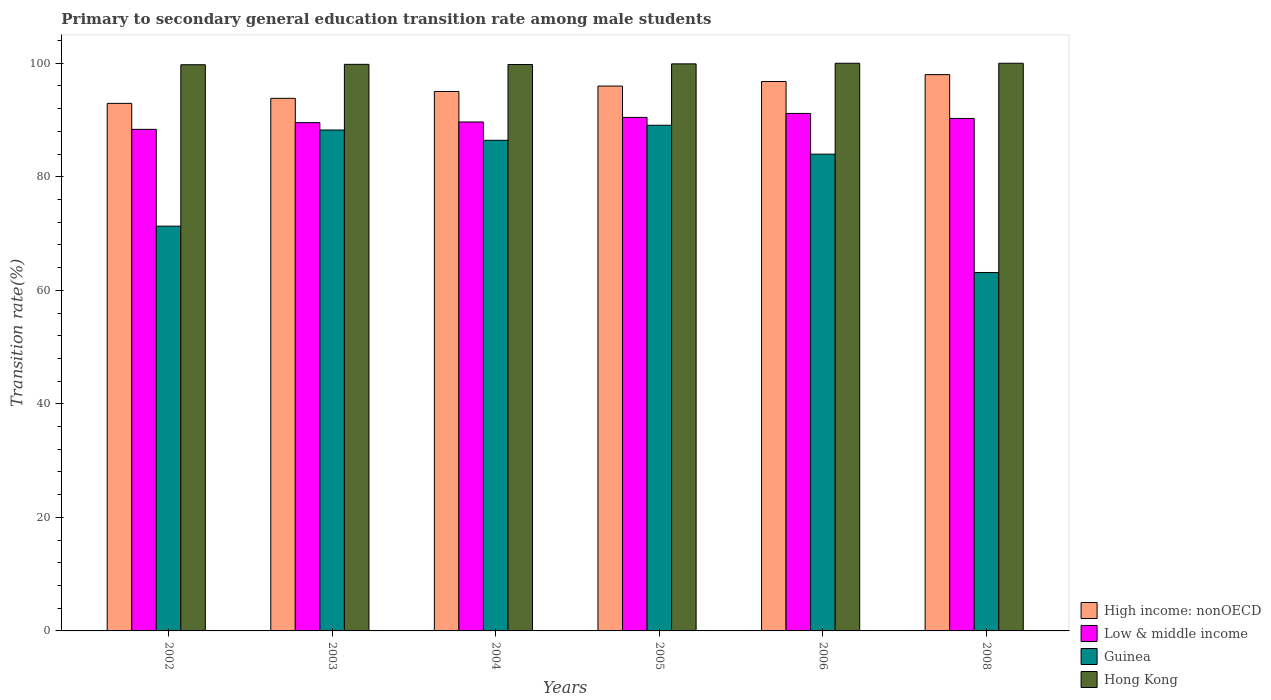Are the number of bars per tick equal to the number of legend labels?
Your response must be concise. Yes. Are the number of bars on each tick of the X-axis equal?
Keep it short and to the point. Yes. How many bars are there on the 6th tick from the right?
Give a very brief answer. 4. In how many cases, is the number of bars for a given year not equal to the number of legend labels?
Your response must be concise. 0. What is the transition rate in High income: nonOECD in 2003?
Give a very brief answer. 93.82. Across all years, what is the minimum transition rate in Hong Kong?
Your response must be concise. 99.74. What is the total transition rate in Hong Kong in the graph?
Keep it short and to the point. 599.22. What is the difference between the transition rate in Low & middle income in 2005 and that in 2008?
Keep it short and to the point. 0.18. What is the difference between the transition rate in Hong Kong in 2008 and the transition rate in Guinea in 2003?
Keep it short and to the point. 11.76. What is the average transition rate in Hong Kong per year?
Your answer should be very brief. 99.87. In the year 2003, what is the difference between the transition rate in High income: nonOECD and transition rate in Guinea?
Offer a terse response. 5.58. In how many years, is the transition rate in Hong Kong greater than 72 %?
Your answer should be compact. 6. What is the ratio of the transition rate in Guinea in 2003 to that in 2008?
Make the answer very short. 1.4. Is the difference between the transition rate in High income: nonOECD in 2002 and 2005 greater than the difference between the transition rate in Guinea in 2002 and 2005?
Offer a very short reply. Yes. What is the difference between the highest and the second highest transition rate in Guinea?
Provide a short and direct response. 0.84. What is the difference between the highest and the lowest transition rate in Guinea?
Offer a very short reply. 25.94. Is it the case that in every year, the sum of the transition rate in High income: nonOECD and transition rate in Guinea is greater than the sum of transition rate in Hong Kong and transition rate in Low & middle income?
Provide a succinct answer. Yes. What does the 1st bar from the right in 2005 represents?
Provide a succinct answer. Hong Kong. Is it the case that in every year, the sum of the transition rate in Hong Kong and transition rate in Guinea is greater than the transition rate in High income: nonOECD?
Your answer should be compact. Yes. What is the difference between two consecutive major ticks on the Y-axis?
Keep it short and to the point. 20. Are the values on the major ticks of Y-axis written in scientific E-notation?
Give a very brief answer. No. Does the graph contain any zero values?
Your answer should be compact. No. How many legend labels are there?
Your answer should be compact. 4. What is the title of the graph?
Give a very brief answer. Primary to secondary general education transition rate among male students. What is the label or title of the X-axis?
Offer a terse response. Years. What is the label or title of the Y-axis?
Make the answer very short. Transition rate(%). What is the Transition rate(%) in High income: nonOECD in 2002?
Provide a succinct answer. 92.93. What is the Transition rate(%) of Low & middle income in 2002?
Ensure brevity in your answer.  88.36. What is the Transition rate(%) in Guinea in 2002?
Ensure brevity in your answer.  71.3. What is the Transition rate(%) of Hong Kong in 2002?
Provide a short and direct response. 99.74. What is the Transition rate(%) of High income: nonOECD in 2003?
Give a very brief answer. 93.82. What is the Transition rate(%) in Low & middle income in 2003?
Provide a short and direct response. 89.54. What is the Transition rate(%) in Guinea in 2003?
Offer a very short reply. 88.24. What is the Transition rate(%) in Hong Kong in 2003?
Make the answer very short. 99.81. What is the Transition rate(%) of High income: nonOECD in 2004?
Keep it short and to the point. 95.03. What is the Transition rate(%) of Low & middle income in 2004?
Ensure brevity in your answer.  89.66. What is the Transition rate(%) in Guinea in 2004?
Offer a terse response. 86.43. What is the Transition rate(%) of Hong Kong in 2004?
Make the answer very short. 99.78. What is the Transition rate(%) of High income: nonOECD in 2005?
Your answer should be compact. 95.98. What is the Transition rate(%) of Low & middle income in 2005?
Your answer should be compact. 90.46. What is the Transition rate(%) in Guinea in 2005?
Offer a terse response. 89.08. What is the Transition rate(%) of Hong Kong in 2005?
Provide a short and direct response. 99.89. What is the Transition rate(%) in High income: nonOECD in 2006?
Offer a very short reply. 96.79. What is the Transition rate(%) in Low & middle income in 2006?
Your response must be concise. 91.16. What is the Transition rate(%) of Guinea in 2006?
Your response must be concise. 83.99. What is the Transition rate(%) of High income: nonOECD in 2008?
Your answer should be compact. 98. What is the Transition rate(%) in Low & middle income in 2008?
Provide a short and direct response. 90.28. What is the Transition rate(%) of Guinea in 2008?
Give a very brief answer. 63.14. Across all years, what is the maximum Transition rate(%) of High income: nonOECD?
Ensure brevity in your answer.  98. Across all years, what is the maximum Transition rate(%) in Low & middle income?
Offer a terse response. 91.16. Across all years, what is the maximum Transition rate(%) in Guinea?
Offer a terse response. 89.08. Across all years, what is the minimum Transition rate(%) of High income: nonOECD?
Provide a short and direct response. 92.93. Across all years, what is the minimum Transition rate(%) of Low & middle income?
Offer a very short reply. 88.36. Across all years, what is the minimum Transition rate(%) in Guinea?
Make the answer very short. 63.14. Across all years, what is the minimum Transition rate(%) in Hong Kong?
Ensure brevity in your answer.  99.74. What is the total Transition rate(%) in High income: nonOECD in the graph?
Your response must be concise. 572.55. What is the total Transition rate(%) in Low & middle income in the graph?
Provide a short and direct response. 539.45. What is the total Transition rate(%) in Guinea in the graph?
Keep it short and to the point. 482.18. What is the total Transition rate(%) of Hong Kong in the graph?
Offer a very short reply. 599.22. What is the difference between the Transition rate(%) of High income: nonOECD in 2002 and that in 2003?
Make the answer very short. -0.88. What is the difference between the Transition rate(%) in Low & middle income in 2002 and that in 2003?
Keep it short and to the point. -1.18. What is the difference between the Transition rate(%) in Guinea in 2002 and that in 2003?
Provide a succinct answer. -16.94. What is the difference between the Transition rate(%) in Hong Kong in 2002 and that in 2003?
Provide a short and direct response. -0.07. What is the difference between the Transition rate(%) in High income: nonOECD in 2002 and that in 2004?
Your answer should be compact. -2.09. What is the difference between the Transition rate(%) of Low & middle income in 2002 and that in 2004?
Offer a terse response. -1.3. What is the difference between the Transition rate(%) of Guinea in 2002 and that in 2004?
Make the answer very short. -15.13. What is the difference between the Transition rate(%) in Hong Kong in 2002 and that in 2004?
Provide a succinct answer. -0.04. What is the difference between the Transition rate(%) of High income: nonOECD in 2002 and that in 2005?
Your answer should be very brief. -3.05. What is the difference between the Transition rate(%) in Low & middle income in 2002 and that in 2005?
Keep it short and to the point. -2.1. What is the difference between the Transition rate(%) in Guinea in 2002 and that in 2005?
Ensure brevity in your answer.  -17.78. What is the difference between the Transition rate(%) of Hong Kong in 2002 and that in 2005?
Your response must be concise. -0.16. What is the difference between the Transition rate(%) of High income: nonOECD in 2002 and that in 2006?
Give a very brief answer. -3.85. What is the difference between the Transition rate(%) in Low & middle income in 2002 and that in 2006?
Provide a short and direct response. -2.81. What is the difference between the Transition rate(%) in Guinea in 2002 and that in 2006?
Your answer should be very brief. -12.68. What is the difference between the Transition rate(%) in Hong Kong in 2002 and that in 2006?
Keep it short and to the point. -0.26. What is the difference between the Transition rate(%) in High income: nonOECD in 2002 and that in 2008?
Give a very brief answer. -5.06. What is the difference between the Transition rate(%) in Low & middle income in 2002 and that in 2008?
Provide a short and direct response. -1.92. What is the difference between the Transition rate(%) in Guinea in 2002 and that in 2008?
Keep it short and to the point. 8.16. What is the difference between the Transition rate(%) in Hong Kong in 2002 and that in 2008?
Keep it short and to the point. -0.26. What is the difference between the Transition rate(%) of High income: nonOECD in 2003 and that in 2004?
Your answer should be compact. -1.21. What is the difference between the Transition rate(%) of Low & middle income in 2003 and that in 2004?
Your answer should be compact. -0.12. What is the difference between the Transition rate(%) in Guinea in 2003 and that in 2004?
Provide a succinct answer. 1.81. What is the difference between the Transition rate(%) in Hong Kong in 2003 and that in 2004?
Ensure brevity in your answer.  0.03. What is the difference between the Transition rate(%) in High income: nonOECD in 2003 and that in 2005?
Provide a succinct answer. -2.16. What is the difference between the Transition rate(%) of Low & middle income in 2003 and that in 2005?
Provide a short and direct response. -0.92. What is the difference between the Transition rate(%) of Guinea in 2003 and that in 2005?
Keep it short and to the point. -0.84. What is the difference between the Transition rate(%) of Hong Kong in 2003 and that in 2005?
Offer a terse response. -0.08. What is the difference between the Transition rate(%) in High income: nonOECD in 2003 and that in 2006?
Offer a very short reply. -2.97. What is the difference between the Transition rate(%) of Low & middle income in 2003 and that in 2006?
Your answer should be very brief. -1.63. What is the difference between the Transition rate(%) of Guinea in 2003 and that in 2006?
Ensure brevity in your answer.  4.25. What is the difference between the Transition rate(%) in Hong Kong in 2003 and that in 2006?
Provide a short and direct response. -0.19. What is the difference between the Transition rate(%) in High income: nonOECD in 2003 and that in 2008?
Provide a succinct answer. -4.18. What is the difference between the Transition rate(%) in Low & middle income in 2003 and that in 2008?
Offer a terse response. -0.74. What is the difference between the Transition rate(%) of Guinea in 2003 and that in 2008?
Offer a very short reply. 25.1. What is the difference between the Transition rate(%) in Hong Kong in 2003 and that in 2008?
Your answer should be very brief. -0.19. What is the difference between the Transition rate(%) in High income: nonOECD in 2004 and that in 2005?
Ensure brevity in your answer.  -0.95. What is the difference between the Transition rate(%) of Low & middle income in 2004 and that in 2005?
Make the answer very short. -0.8. What is the difference between the Transition rate(%) of Guinea in 2004 and that in 2005?
Your answer should be compact. -2.65. What is the difference between the Transition rate(%) of Hong Kong in 2004 and that in 2005?
Your answer should be compact. -0.11. What is the difference between the Transition rate(%) of High income: nonOECD in 2004 and that in 2006?
Give a very brief answer. -1.76. What is the difference between the Transition rate(%) in Low & middle income in 2004 and that in 2006?
Your answer should be compact. -1.51. What is the difference between the Transition rate(%) in Guinea in 2004 and that in 2006?
Keep it short and to the point. 2.44. What is the difference between the Transition rate(%) in Hong Kong in 2004 and that in 2006?
Offer a terse response. -0.22. What is the difference between the Transition rate(%) in High income: nonOECD in 2004 and that in 2008?
Ensure brevity in your answer.  -2.97. What is the difference between the Transition rate(%) of Low & middle income in 2004 and that in 2008?
Give a very brief answer. -0.62. What is the difference between the Transition rate(%) of Guinea in 2004 and that in 2008?
Your answer should be very brief. 23.29. What is the difference between the Transition rate(%) of Hong Kong in 2004 and that in 2008?
Keep it short and to the point. -0.22. What is the difference between the Transition rate(%) of High income: nonOECD in 2005 and that in 2006?
Provide a succinct answer. -0.8. What is the difference between the Transition rate(%) of Low & middle income in 2005 and that in 2006?
Offer a very short reply. -0.7. What is the difference between the Transition rate(%) of Guinea in 2005 and that in 2006?
Ensure brevity in your answer.  5.09. What is the difference between the Transition rate(%) in Hong Kong in 2005 and that in 2006?
Ensure brevity in your answer.  -0.11. What is the difference between the Transition rate(%) in High income: nonOECD in 2005 and that in 2008?
Offer a terse response. -2.01. What is the difference between the Transition rate(%) of Low & middle income in 2005 and that in 2008?
Offer a very short reply. 0.18. What is the difference between the Transition rate(%) in Guinea in 2005 and that in 2008?
Your answer should be compact. 25.94. What is the difference between the Transition rate(%) in Hong Kong in 2005 and that in 2008?
Give a very brief answer. -0.11. What is the difference between the Transition rate(%) of High income: nonOECD in 2006 and that in 2008?
Provide a succinct answer. -1.21. What is the difference between the Transition rate(%) in Low & middle income in 2006 and that in 2008?
Offer a very short reply. 0.88. What is the difference between the Transition rate(%) of Guinea in 2006 and that in 2008?
Provide a short and direct response. 20.84. What is the difference between the Transition rate(%) of Hong Kong in 2006 and that in 2008?
Make the answer very short. 0. What is the difference between the Transition rate(%) in High income: nonOECD in 2002 and the Transition rate(%) in Low & middle income in 2003?
Your answer should be compact. 3.4. What is the difference between the Transition rate(%) in High income: nonOECD in 2002 and the Transition rate(%) in Guinea in 2003?
Make the answer very short. 4.69. What is the difference between the Transition rate(%) of High income: nonOECD in 2002 and the Transition rate(%) of Hong Kong in 2003?
Offer a terse response. -6.88. What is the difference between the Transition rate(%) in Low & middle income in 2002 and the Transition rate(%) in Guinea in 2003?
Offer a terse response. 0.12. What is the difference between the Transition rate(%) in Low & middle income in 2002 and the Transition rate(%) in Hong Kong in 2003?
Your answer should be compact. -11.45. What is the difference between the Transition rate(%) in Guinea in 2002 and the Transition rate(%) in Hong Kong in 2003?
Your answer should be compact. -28.51. What is the difference between the Transition rate(%) in High income: nonOECD in 2002 and the Transition rate(%) in Low & middle income in 2004?
Give a very brief answer. 3.28. What is the difference between the Transition rate(%) in High income: nonOECD in 2002 and the Transition rate(%) in Guinea in 2004?
Provide a succinct answer. 6.51. What is the difference between the Transition rate(%) in High income: nonOECD in 2002 and the Transition rate(%) in Hong Kong in 2004?
Your answer should be compact. -6.85. What is the difference between the Transition rate(%) in Low & middle income in 2002 and the Transition rate(%) in Guinea in 2004?
Provide a succinct answer. 1.93. What is the difference between the Transition rate(%) of Low & middle income in 2002 and the Transition rate(%) of Hong Kong in 2004?
Make the answer very short. -11.42. What is the difference between the Transition rate(%) in Guinea in 2002 and the Transition rate(%) in Hong Kong in 2004?
Provide a succinct answer. -28.48. What is the difference between the Transition rate(%) in High income: nonOECD in 2002 and the Transition rate(%) in Low & middle income in 2005?
Your answer should be very brief. 2.48. What is the difference between the Transition rate(%) in High income: nonOECD in 2002 and the Transition rate(%) in Guinea in 2005?
Give a very brief answer. 3.86. What is the difference between the Transition rate(%) of High income: nonOECD in 2002 and the Transition rate(%) of Hong Kong in 2005?
Offer a terse response. -6.96. What is the difference between the Transition rate(%) of Low & middle income in 2002 and the Transition rate(%) of Guinea in 2005?
Offer a very short reply. -0.72. What is the difference between the Transition rate(%) in Low & middle income in 2002 and the Transition rate(%) in Hong Kong in 2005?
Ensure brevity in your answer.  -11.54. What is the difference between the Transition rate(%) of Guinea in 2002 and the Transition rate(%) of Hong Kong in 2005?
Your answer should be very brief. -28.59. What is the difference between the Transition rate(%) in High income: nonOECD in 2002 and the Transition rate(%) in Low & middle income in 2006?
Offer a very short reply. 1.77. What is the difference between the Transition rate(%) of High income: nonOECD in 2002 and the Transition rate(%) of Guinea in 2006?
Offer a terse response. 8.95. What is the difference between the Transition rate(%) of High income: nonOECD in 2002 and the Transition rate(%) of Hong Kong in 2006?
Provide a succinct answer. -7.07. What is the difference between the Transition rate(%) of Low & middle income in 2002 and the Transition rate(%) of Guinea in 2006?
Give a very brief answer. 4.37. What is the difference between the Transition rate(%) in Low & middle income in 2002 and the Transition rate(%) in Hong Kong in 2006?
Ensure brevity in your answer.  -11.64. What is the difference between the Transition rate(%) in Guinea in 2002 and the Transition rate(%) in Hong Kong in 2006?
Offer a very short reply. -28.7. What is the difference between the Transition rate(%) of High income: nonOECD in 2002 and the Transition rate(%) of Low & middle income in 2008?
Provide a short and direct response. 2.66. What is the difference between the Transition rate(%) of High income: nonOECD in 2002 and the Transition rate(%) of Guinea in 2008?
Your answer should be very brief. 29.79. What is the difference between the Transition rate(%) in High income: nonOECD in 2002 and the Transition rate(%) in Hong Kong in 2008?
Ensure brevity in your answer.  -7.07. What is the difference between the Transition rate(%) of Low & middle income in 2002 and the Transition rate(%) of Guinea in 2008?
Your answer should be compact. 25.21. What is the difference between the Transition rate(%) of Low & middle income in 2002 and the Transition rate(%) of Hong Kong in 2008?
Your answer should be very brief. -11.64. What is the difference between the Transition rate(%) of Guinea in 2002 and the Transition rate(%) of Hong Kong in 2008?
Offer a very short reply. -28.7. What is the difference between the Transition rate(%) of High income: nonOECD in 2003 and the Transition rate(%) of Low & middle income in 2004?
Give a very brief answer. 4.16. What is the difference between the Transition rate(%) in High income: nonOECD in 2003 and the Transition rate(%) in Guinea in 2004?
Make the answer very short. 7.39. What is the difference between the Transition rate(%) of High income: nonOECD in 2003 and the Transition rate(%) of Hong Kong in 2004?
Offer a terse response. -5.96. What is the difference between the Transition rate(%) in Low & middle income in 2003 and the Transition rate(%) in Guinea in 2004?
Your answer should be very brief. 3.11. What is the difference between the Transition rate(%) in Low & middle income in 2003 and the Transition rate(%) in Hong Kong in 2004?
Offer a very short reply. -10.24. What is the difference between the Transition rate(%) in Guinea in 2003 and the Transition rate(%) in Hong Kong in 2004?
Your answer should be very brief. -11.54. What is the difference between the Transition rate(%) of High income: nonOECD in 2003 and the Transition rate(%) of Low & middle income in 2005?
Your answer should be very brief. 3.36. What is the difference between the Transition rate(%) of High income: nonOECD in 2003 and the Transition rate(%) of Guinea in 2005?
Give a very brief answer. 4.74. What is the difference between the Transition rate(%) in High income: nonOECD in 2003 and the Transition rate(%) in Hong Kong in 2005?
Provide a short and direct response. -6.07. What is the difference between the Transition rate(%) of Low & middle income in 2003 and the Transition rate(%) of Guinea in 2005?
Keep it short and to the point. 0.46. What is the difference between the Transition rate(%) in Low & middle income in 2003 and the Transition rate(%) in Hong Kong in 2005?
Make the answer very short. -10.36. What is the difference between the Transition rate(%) in Guinea in 2003 and the Transition rate(%) in Hong Kong in 2005?
Keep it short and to the point. -11.65. What is the difference between the Transition rate(%) of High income: nonOECD in 2003 and the Transition rate(%) of Low & middle income in 2006?
Give a very brief answer. 2.66. What is the difference between the Transition rate(%) of High income: nonOECD in 2003 and the Transition rate(%) of Guinea in 2006?
Offer a very short reply. 9.83. What is the difference between the Transition rate(%) in High income: nonOECD in 2003 and the Transition rate(%) in Hong Kong in 2006?
Your answer should be compact. -6.18. What is the difference between the Transition rate(%) of Low & middle income in 2003 and the Transition rate(%) of Guinea in 2006?
Ensure brevity in your answer.  5.55. What is the difference between the Transition rate(%) of Low & middle income in 2003 and the Transition rate(%) of Hong Kong in 2006?
Offer a terse response. -10.46. What is the difference between the Transition rate(%) in Guinea in 2003 and the Transition rate(%) in Hong Kong in 2006?
Ensure brevity in your answer.  -11.76. What is the difference between the Transition rate(%) of High income: nonOECD in 2003 and the Transition rate(%) of Low & middle income in 2008?
Your response must be concise. 3.54. What is the difference between the Transition rate(%) in High income: nonOECD in 2003 and the Transition rate(%) in Guinea in 2008?
Provide a short and direct response. 30.68. What is the difference between the Transition rate(%) in High income: nonOECD in 2003 and the Transition rate(%) in Hong Kong in 2008?
Ensure brevity in your answer.  -6.18. What is the difference between the Transition rate(%) in Low & middle income in 2003 and the Transition rate(%) in Guinea in 2008?
Offer a very short reply. 26.4. What is the difference between the Transition rate(%) of Low & middle income in 2003 and the Transition rate(%) of Hong Kong in 2008?
Your response must be concise. -10.46. What is the difference between the Transition rate(%) of Guinea in 2003 and the Transition rate(%) of Hong Kong in 2008?
Ensure brevity in your answer.  -11.76. What is the difference between the Transition rate(%) of High income: nonOECD in 2004 and the Transition rate(%) of Low & middle income in 2005?
Provide a short and direct response. 4.57. What is the difference between the Transition rate(%) of High income: nonOECD in 2004 and the Transition rate(%) of Guinea in 2005?
Your answer should be very brief. 5.95. What is the difference between the Transition rate(%) in High income: nonOECD in 2004 and the Transition rate(%) in Hong Kong in 2005?
Your response must be concise. -4.87. What is the difference between the Transition rate(%) in Low & middle income in 2004 and the Transition rate(%) in Guinea in 2005?
Offer a very short reply. 0.58. What is the difference between the Transition rate(%) in Low & middle income in 2004 and the Transition rate(%) in Hong Kong in 2005?
Keep it short and to the point. -10.24. What is the difference between the Transition rate(%) in Guinea in 2004 and the Transition rate(%) in Hong Kong in 2005?
Provide a short and direct response. -13.46. What is the difference between the Transition rate(%) in High income: nonOECD in 2004 and the Transition rate(%) in Low & middle income in 2006?
Provide a short and direct response. 3.87. What is the difference between the Transition rate(%) in High income: nonOECD in 2004 and the Transition rate(%) in Guinea in 2006?
Offer a very short reply. 11.04. What is the difference between the Transition rate(%) in High income: nonOECD in 2004 and the Transition rate(%) in Hong Kong in 2006?
Give a very brief answer. -4.97. What is the difference between the Transition rate(%) of Low & middle income in 2004 and the Transition rate(%) of Guinea in 2006?
Your answer should be compact. 5.67. What is the difference between the Transition rate(%) in Low & middle income in 2004 and the Transition rate(%) in Hong Kong in 2006?
Your response must be concise. -10.34. What is the difference between the Transition rate(%) in Guinea in 2004 and the Transition rate(%) in Hong Kong in 2006?
Give a very brief answer. -13.57. What is the difference between the Transition rate(%) of High income: nonOECD in 2004 and the Transition rate(%) of Low & middle income in 2008?
Keep it short and to the point. 4.75. What is the difference between the Transition rate(%) in High income: nonOECD in 2004 and the Transition rate(%) in Guinea in 2008?
Provide a succinct answer. 31.89. What is the difference between the Transition rate(%) of High income: nonOECD in 2004 and the Transition rate(%) of Hong Kong in 2008?
Provide a short and direct response. -4.97. What is the difference between the Transition rate(%) in Low & middle income in 2004 and the Transition rate(%) in Guinea in 2008?
Ensure brevity in your answer.  26.51. What is the difference between the Transition rate(%) of Low & middle income in 2004 and the Transition rate(%) of Hong Kong in 2008?
Ensure brevity in your answer.  -10.34. What is the difference between the Transition rate(%) of Guinea in 2004 and the Transition rate(%) of Hong Kong in 2008?
Make the answer very short. -13.57. What is the difference between the Transition rate(%) in High income: nonOECD in 2005 and the Transition rate(%) in Low & middle income in 2006?
Offer a terse response. 4.82. What is the difference between the Transition rate(%) of High income: nonOECD in 2005 and the Transition rate(%) of Guinea in 2006?
Ensure brevity in your answer.  12. What is the difference between the Transition rate(%) in High income: nonOECD in 2005 and the Transition rate(%) in Hong Kong in 2006?
Your answer should be very brief. -4.02. What is the difference between the Transition rate(%) of Low & middle income in 2005 and the Transition rate(%) of Guinea in 2006?
Provide a succinct answer. 6.47. What is the difference between the Transition rate(%) in Low & middle income in 2005 and the Transition rate(%) in Hong Kong in 2006?
Provide a short and direct response. -9.54. What is the difference between the Transition rate(%) in Guinea in 2005 and the Transition rate(%) in Hong Kong in 2006?
Provide a short and direct response. -10.92. What is the difference between the Transition rate(%) of High income: nonOECD in 2005 and the Transition rate(%) of Low & middle income in 2008?
Your answer should be compact. 5.7. What is the difference between the Transition rate(%) of High income: nonOECD in 2005 and the Transition rate(%) of Guinea in 2008?
Make the answer very short. 32.84. What is the difference between the Transition rate(%) in High income: nonOECD in 2005 and the Transition rate(%) in Hong Kong in 2008?
Your answer should be very brief. -4.02. What is the difference between the Transition rate(%) in Low & middle income in 2005 and the Transition rate(%) in Guinea in 2008?
Provide a short and direct response. 27.32. What is the difference between the Transition rate(%) of Low & middle income in 2005 and the Transition rate(%) of Hong Kong in 2008?
Your answer should be compact. -9.54. What is the difference between the Transition rate(%) in Guinea in 2005 and the Transition rate(%) in Hong Kong in 2008?
Make the answer very short. -10.92. What is the difference between the Transition rate(%) of High income: nonOECD in 2006 and the Transition rate(%) of Low & middle income in 2008?
Make the answer very short. 6.51. What is the difference between the Transition rate(%) in High income: nonOECD in 2006 and the Transition rate(%) in Guinea in 2008?
Ensure brevity in your answer.  33.64. What is the difference between the Transition rate(%) in High income: nonOECD in 2006 and the Transition rate(%) in Hong Kong in 2008?
Provide a short and direct response. -3.21. What is the difference between the Transition rate(%) in Low & middle income in 2006 and the Transition rate(%) in Guinea in 2008?
Provide a short and direct response. 28.02. What is the difference between the Transition rate(%) in Low & middle income in 2006 and the Transition rate(%) in Hong Kong in 2008?
Offer a terse response. -8.84. What is the difference between the Transition rate(%) of Guinea in 2006 and the Transition rate(%) of Hong Kong in 2008?
Make the answer very short. -16.01. What is the average Transition rate(%) in High income: nonOECD per year?
Make the answer very short. 95.42. What is the average Transition rate(%) of Low & middle income per year?
Your answer should be compact. 89.91. What is the average Transition rate(%) in Guinea per year?
Keep it short and to the point. 80.36. What is the average Transition rate(%) in Hong Kong per year?
Provide a short and direct response. 99.87. In the year 2002, what is the difference between the Transition rate(%) of High income: nonOECD and Transition rate(%) of Low & middle income?
Give a very brief answer. 4.58. In the year 2002, what is the difference between the Transition rate(%) of High income: nonOECD and Transition rate(%) of Guinea?
Keep it short and to the point. 21.63. In the year 2002, what is the difference between the Transition rate(%) of High income: nonOECD and Transition rate(%) of Hong Kong?
Keep it short and to the point. -6.8. In the year 2002, what is the difference between the Transition rate(%) of Low & middle income and Transition rate(%) of Guinea?
Give a very brief answer. 17.06. In the year 2002, what is the difference between the Transition rate(%) in Low & middle income and Transition rate(%) in Hong Kong?
Make the answer very short. -11.38. In the year 2002, what is the difference between the Transition rate(%) of Guinea and Transition rate(%) of Hong Kong?
Make the answer very short. -28.44. In the year 2003, what is the difference between the Transition rate(%) of High income: nonOECD and Transition rate(%) of Low & middle income?
Make the answer very short. 4.28. In the year 2003, what is the difference between the Transition rate(%) in High income: nonOECD and Transition rate(%) in Guinea?
Ensure brevity in your answer.  5.58. In the year 2003, what is the difference between the Transition rate(%) in High income: nonOECD and Transition rate(%) in Hong Kong?
Make the answer very short. -5.99. In the year 2003, what is the difference between the Transition rate(%) of Low & middle income and Transition rate(%) of Guinea?
Offer a terse response. 1.3. In the year 2003, what is the difference between the Transition rate(%) of Low & middle income and Transition rate(%) of Hong Kong?
Offer a terse response. -10.27. In the year 2003, what is the difference between the Transition rate(%) in Guinea and Transition rate(%) in Hong Kong?
Ensure brevity in your answer.  -11.57. In the year 2004, what is the difference between the Transition rate(%) in High income: nonOECD and Transition rate(%) in Low & middle income?
Your response must be concise. 5.37. In the year 2004, what is the difference between the Transition rate(%) of High income: nonOECD and Transition rate(%) of Guinea?
Provide a short and direct response. 8.6. In the year 2004, what is the difference between the Transition rate(%) in High income: nonOECD and Transition rate(%) in Hong Kong?
Your answer should be very brief. -4.75. In the year 2004, what is the difference between the Transition rate(%) in Low & middle income and Transition rate(%) in Guinea?
Your answer should be very brief. 3.23. In the year 2004, what is the difference between the Transition rate(%) in Low & middle income and Transition rate(%) in Hong Kong?
Provide a succinct answer. -10.12. In the year 2004, what is the difference between the Transition rate(%) in Guinea and Transition rate(%) in Hong Kong?
Your answer should be very brief. -13.35. In the year 2005, what is the difference between the Transition rate(%) of High income: nonOECD and Transition rate(%) of Low & middle income?
Keep it short and to the point. 5.52. In the year 2005, what is the difference between the Transition rate(%) of High income: nonOECD and Transition rate(%) of Guinea?
Give a very brief answer. 6.9. In the year 2005, what is the difference between the Transition rate(%) of High income: nonOECD and Transition rate(%) of Hong Kong?
Make the answer very short. -3.91. In the year 2005, what is the difference between the Transition rate(%) of Low & middle income and Transition rate(%) of Guinea?
Your response must be concise. 1.38. In the year 2005, what is the difference between the Transition rate(%) in Low & middle income and Transition rate(%) in Hong Kong?
Your response must be concise. -9.43. In the year 2005, what is the difference between the Transition rate(%) of Guinea and Transition rate(%) of Hong Kong?
Make the answer very short. -10.81. In the year 2006, what is the difference between the Transition rate(%) in High income: nonOECD and Transition rate(%) in Low & middle income?
Make the answer very short. 5.62. In the year 2006, what is the difference between the Transition rate(%) in High income: nonOECD and Transition rate(%) in Guinea?
Offer a terse response. 12.8. In the year 2006, what is the difference between the Transition rate(%) of High income: nonOECD and Transition rate(%) of Hong Kong?
Provide a short and direct response. -3.21. In the year 2006, what is the difference between the Transition rate(%) of Low & middle income and Transition rate(%) of Guinea?
Offer a terse response. 7.18. In the year 2006, what is the difference between the Transition rate(%) of Low & middle income and Transition rate(%) of Hong Kong?
Your answer should be very brief. -8.84. In the year 2006, what is the difference between the Transition rate(%) in Guinea and Transition rate(%) in Hong Kong?
Give a very brief answer. -16.01. In the year 2008, what is the difference between the Transition rate(%) of High income: nonOECD and Transition rate(%) of Low & middle income?
Your answer should be compact. 7.72. In the year 2008, what is the difference between the Transition rate(%) of High income: nonOECD and Transition rate(%) of Guinea?
Give a very brief answer. 34.85. In the year 2008, what is the difference between the Transition rate(%) in High income: nonOECD and Transition rate(%) in Hong Kong?
Give a very brief answer. -2. In the year 2008, what is the difference between the Transition rate(%) in Low & middle income and Transition rate(%) in Guinea?
Your answer should be compact. 27.14. In the year 2008, what is the difference between the Transition rate(%) in Low & middle income and Transition rate(%) in Hong Kong?
Offer a terse response. -9.72. In the year 2008, what is the difference between the Transition rate(%) of Guinea and Transition rate(%) of Hong Kong?
Provide a succinct answer. -36.86. What is the ratio of the Transition rate(%) in High income: nonOECD in 2002 to that in 2003?
Your answer should be compact. 0.99. What is the ratio of the Transition rate(%) of Guinea in 2002 to that in 2003?
Provide a succinct answer. 0.81. What is the ratio of the Transition rate(%) in Hong Kong in 2002 to that in 2003?
Keep it short and to the point. 1. What is the ratio of the Transition rate(%) of Low & middle income in 2002 to that in 2004?
Make the answer very short. 0.99. What is the ratio of the Transition rate(%) in Guinea in 2002 to that in 2004?
Your answer should be compact. 0.82. What is the ratio of the Transition rate(%) in Hong Kong in 2002 to that in 2004?
Your answer should be very brief. 1. What is the ratio of the Transition rate(%) of High income: nonOECD in 2002 to that in 2005?
Offer a very short reply. 0.97. What is the ratio of the Transition rate(%) in Low & middle income in 2002 to that in 2005?
Your answer should be compact. 0.98. What is the ratio of the Transition rate(%) in Guinea in 2002 to that in 2005?
Keep it short and to the point. 0.8. What is the ratio of the Transition rate(%) of Hong Kong in 2002 to that in 2005?
Give a very brief answer. 1. What is the ratio of the Transition rate(%) in High income: nonOECD in 2002 to that in 2006?
Your answer should be very brief. 0.96. What is the ratio of the Transition rate(%) of Low & middle income in 2002 to that in 2006?
Provide a succinct answer. 0.97. What is the ratio of the Transition rate(%) in Guinea in 2002 to that in 2006?
Provide a succinct answer. 0.85. What is the ratio of the Transition rate(%) in High income: nonOECD in 2002 to that in 2008?
Make the answer very short. 0.95. What is the ratio of the Transition rate(%) of Low & middle income in 2002 to that in 2008?
Offer a terse response. 0.98. What is the ratio of the Transition rate(%) of Guinea in 2002 to that in 2008?
Keep it short and to the point. 1.13. What is the ratio of the Transition rate(%) in Hong Kong in 2002 to that in 2008?
Provide a succinct answer. 1. What is the ratio of the Transition rate(%) in High income: nonOECD in 2003 to that in 2004?
Make the answer very short. 0.99. What is the ratio of the Transition rate(%) in Low & middle income in 2003 to that in 2004?
Keep it short and to the point. 1. What is the ratio of the Transition rate(%) of Hong Kong in 2003 to that in 2004?
Your response must be concise. 1. What is the ratio of the Transition rate(%) in High income: nonOECD in 2003 to that in 2005?
Ensure brevity in your answer.  0.98. What is the ratio of the Transition rate(%) of Guinea in 2003 to that in 2005?
Make the answer very short. 0.99. What is the ratio of the Transition rate(%) in High income: nonOECD in 2003 to that in 2006?
Your response must be concise. 0.97. What is the ratio of the Transition rate(%) in Low & middle income in 2003 to that in 2006?
Provide a succinct answer. 0.98. What is the ratio of the Transition rate(%) of Guinea in 2003 to that in 2006?
Offer a very short reply. 1.05. What is the ratio of the Transition rate(%) in High income: nonOECD in 2003 to that in 2008?
Your answer should be compact. 0.96. What is the ratio of the Transition rate(%) in Guinea in 2003 to that in 2008?
Keep it short and to the point. 1.4. What is the ratio of the Transition rate(%) of High income: nonOECD in 2004 to that in 2005?
Provide a short and direct response. 0.99. What is the ratio of the Transition rate(%) in Guinea in 2004 to that in 2005?
Make the answer very short. 0.97. What is the ratio of the Transition rate(%) in High income: nonOECD in 2004 to that in 2006?
Give a very brief answer. 0.98. What is the ratio of the Transition rate(%) in Low & middle income in 2004 to that in 2006?
Offer a terse response. 0.98. What is the ratio of the Transition rate(%) in Guinea in 2004 to that in 2006?
Provide a short and direct response. 1.03. What is the ratio of the Transition rate(%) in High income: nonOECD in 2004 to that in 2008?
Your response must be concise. 0.97. What is the ratio of the Transition rate(%) in Guinea in 2004 to that in 2008?
Make the answer very short. 1.37. What is the ratio of the Transition rate(%) in Guinea in 2005 to that in 2006?
Make the answer very short. 1.06. What is the ratio of the Transition rate(%) in Hong Kong in 2005 to that in 2006?
Give a very brief answer. 1. What is the ratio of the Transition rate(%) of High income: nonOECD in 2005 to that in 2008?
Offer a terse response. 0.98. What is the ratio of the Transition rate(%) of Guinea in 2005 to that in 2008?
Provide a succinct answer. 1.41. What is the ratio of the Transition rate(%) of Hong Kong in 2005 to that in 2008?
Give a very brief answer. 1. What is the ratio of the Transition rate(%) of High income: nonOECD in 2006 to that in 2008?
Offer a very short reply. 0.99. What is the ratio of the Transition rate(%) in Low & middle income in 2006 to that in 2008?
Ensure brevity in your answer.  1.01. What is the ratio of the Transition rate(%) in Guinea in 2006 to that in 2008?
Ensure brevity in your answer.  1.33. What is the ratio of the Transition rate(%) in Hong Kong in 2006 to that in 2008?
Keep it short and to the point. 1. What is the difference between the highest and the second highest Transition rate(%) in High income: nonOECD?
Ensure brevity in your answer.  1.21. What is the difference between the highest and the second highest Transition rate(%) of Low & middle income?
Keep it short and to the point. 0.7. What is the difference between the highest and the second highest Transition rate(%) in Guinea?
Provide a short and direct response. 0.84. What is the difference between the highest and the lowest Transition rate(%) of High income: nonOECD?
Ensure brevity in your answer.  5.06. What is the difference between the highest and the lowest Transition rate(%) of Low & middle income?
Ensure brevity in your answer.  2.81. What is the difference between the highest and the lowest Transition rate(%) of Guinea?
Offer a terse response. 25.94. What is the difference between the highest and the lowest Transition rate(%) of Hong Kong?
Make the answer very short. 0.26. 